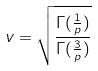<formula> <loc_0><loc_0><loc_500><loc_500>v = \sqrt { \frac { \Gamma ( \frac { 1 } { p } ) } { \Gamma ( \frac { 3 } { p } ) } }</formula> 